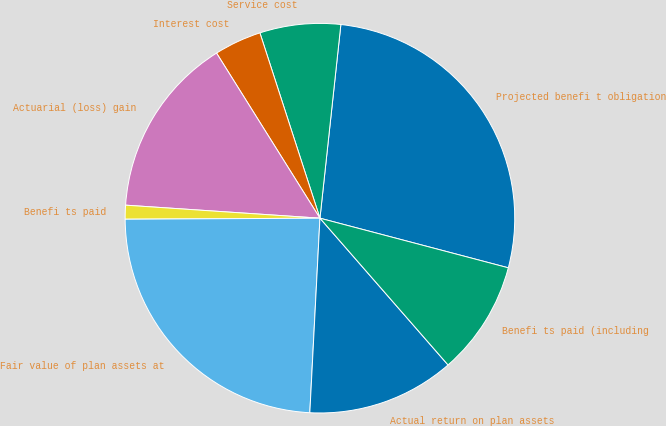<chart> <loc_0><loc_0><loc_500><loc_500><pie_chart><fcel>Projected benefi t obligation<fcel>Service cost<fcel>Interest cost<fcel>Actuarial (loss) gain<fcel>Benefi ts paid<fcel>Fair value of plan assets at<fcel>Actual return on plan assets<fcel>Benefi ts paid (including<nl><fcel>27.39%<fcel>6.7%<fcel>3.92%<fcel>15.03%<fcel>1.15%<fcel>24.09%<fcel>12.25%<fcel>9.48%<nl></chart> 